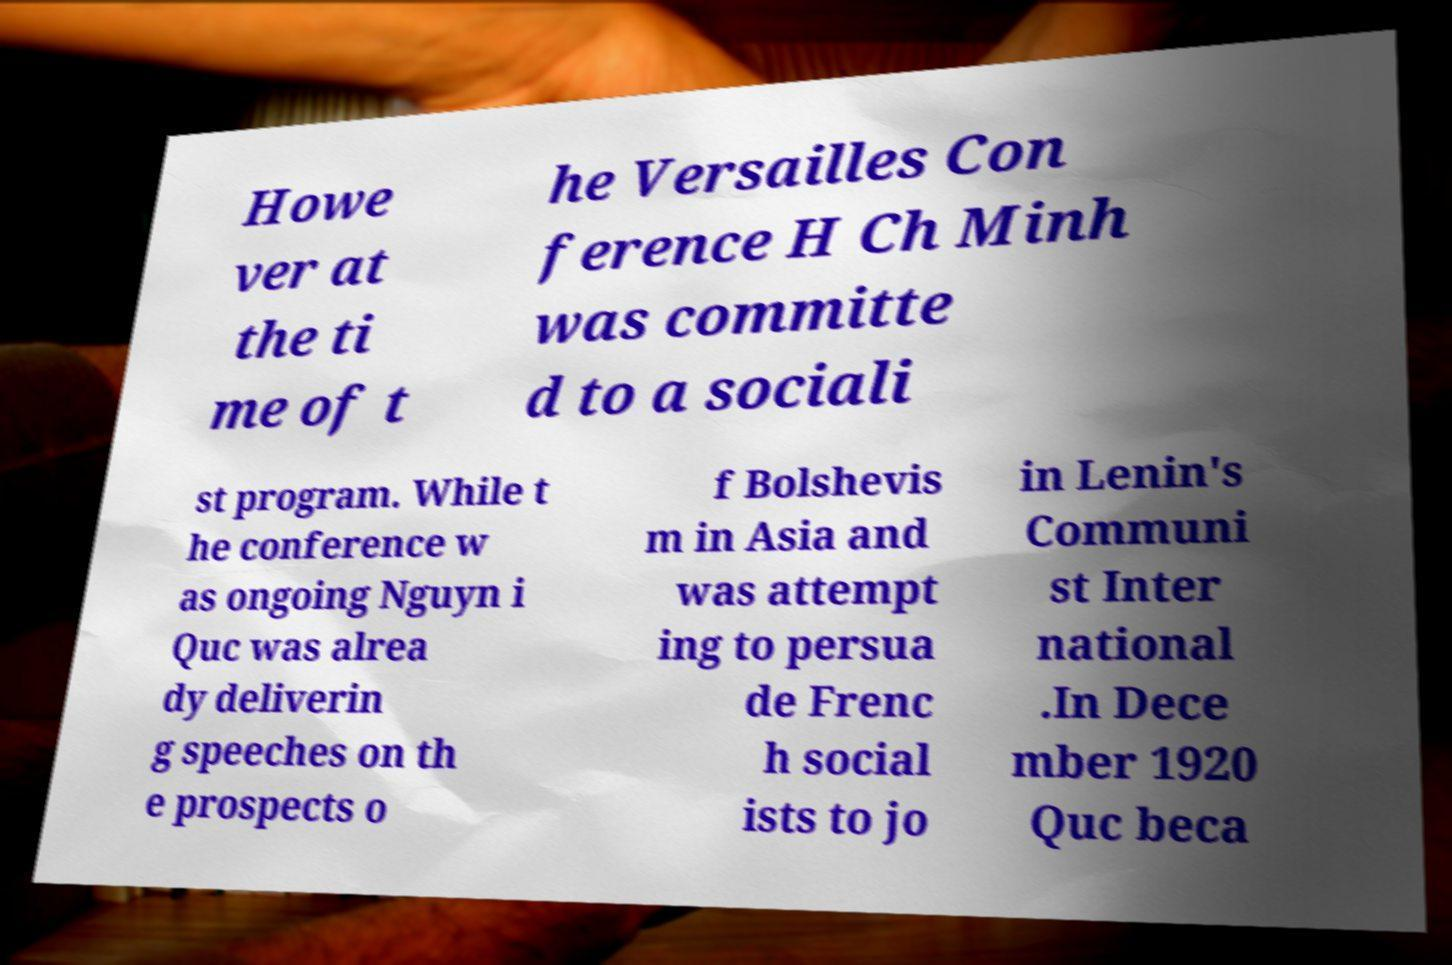Could you assist in decoding the text presented in this image and type it out clearly? Howe ver at the ti me of t he Versailles Con ference H Ch Minh was committe d to a sociali st program. While t he conference w as ongoing Nguyn i Quc was alrea dy deliverin g speeches on th e prospects o f Bolshevis m in Asia and was attempt ing to persua de Frenc h social ists to jo in Lenin's Communi st Inter national .In Dece mber 1920 Quc beca 